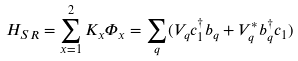Convert formula to latex. <formula><loc_0><loc_0><loc_500><loc_500>H _ { S R } = \sum _ { x = 1 } ^ { 2 } K _ { x } \Phi _ { x } = \sum _ { q } ( V _ { q } c _ { 1 } ^ { \dagger } b _ { q } + V _ { q } ^ { * } b _ { q } ^ { \dagger } c _ { 1 } )</formula> 